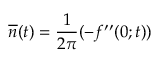Convert formula to latex. <formula><loc_0><loc_0><loc_500><loc_500>\overline { n } ( t ) = \frac { 1 } 2 \pi } ( - f ^ { \prime \prime } ( 0 ; t ) )</formula> 